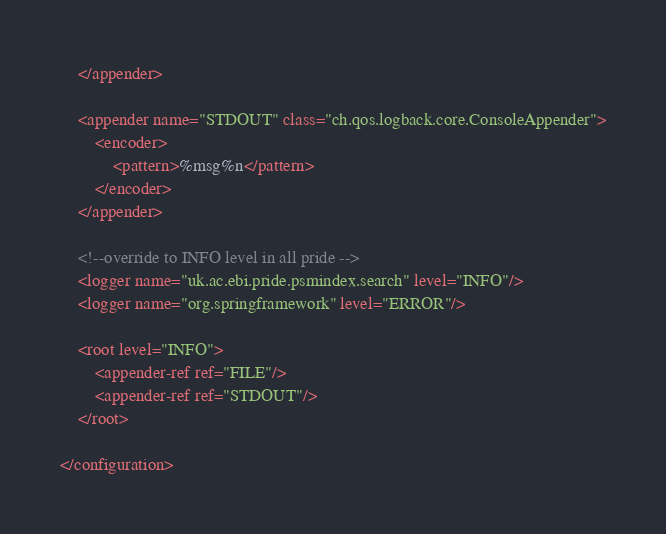Convert code to text. <code><loc_0><loc_0><loc_500><loc_500><_XML_>    </appender>

    <appender name="STDOUT" class="ch.qos.logback.core.ConsoleAppender">
        <encoder>
            <pattern>%msg%n</pattern>
        </encoder>
    </appender>

    <!--override to INFO level in all pride -->
    <logger name="uk.ac.ebi.pride.psmindex.search" level="INFO"/>
    <logger name="org.springframework" level="ERROR"/>

    <root level="INFO">
        <appender-ref ref="FILE"/>
        <appender-ref ref="STDOUT"/>
    </root>

</configuration>
</code> 